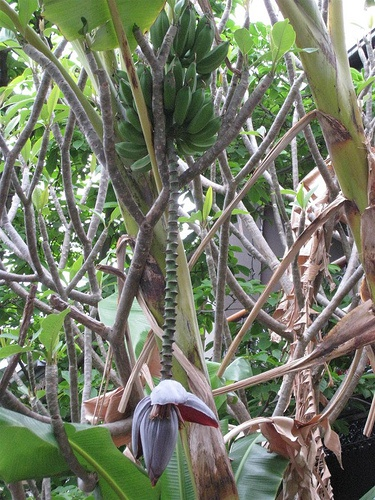Describe the objects in this image and their specific colors. I can see banana in olive, darkgreen, black, and gray tones, banana in olive and darkgreen tones, banana in olive, darkgreen, black, and gray tones, banana in olive, darkgreen, and black tones, and banana in olive and darkgreen tones in this image. 